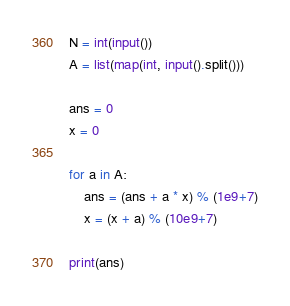Convert code to text. <code><loc_0><loc_0><loc_500><loc_500><_Python_>N = int(input())
A = list(map(int, input().split()))

ans = 0
x = 0

for a in A:
    ans = (ans + a * x) % (1e9+7)
    x = (x + a) % (10e9+7)

print(ans)
</code> 